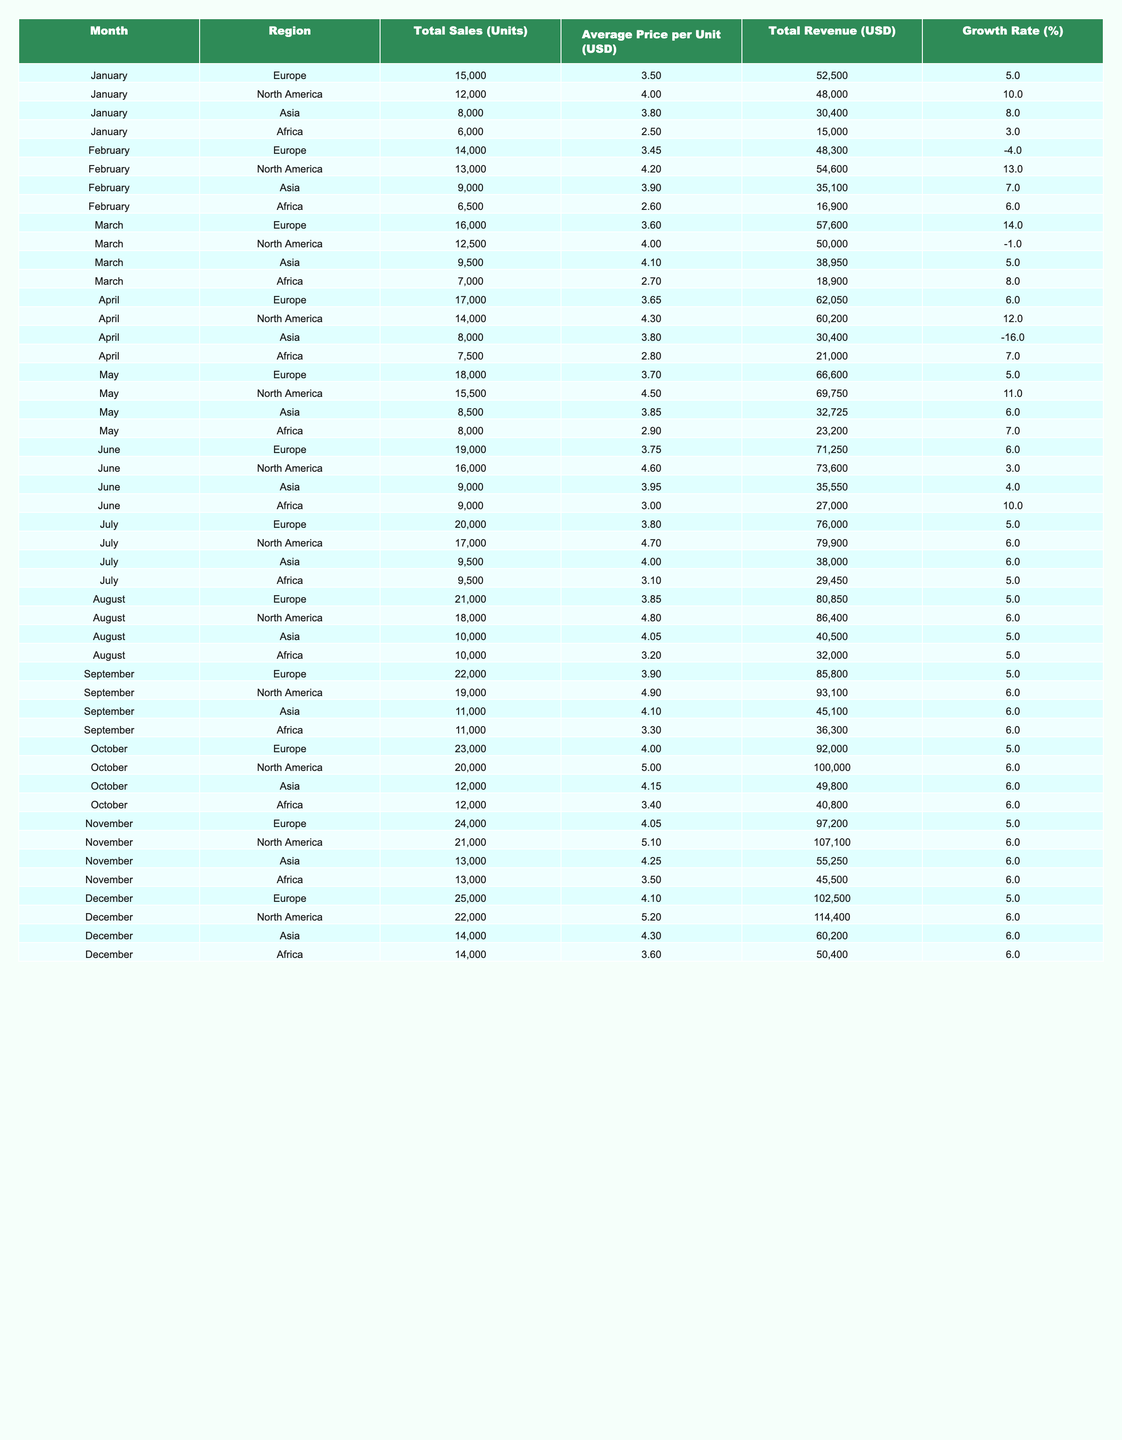What was the total revenue from citrus sales in Europe during November? In November, the total revenue from Europe is listed as $97,200.
Answer: $97,200 Which region had the highest average price per unit in October? In October, North America had the highest average price at $5.00 per unit.
Answer: North America What is the total number of units sold across all regions in December? The total units sold in December across all regions are: 25,000 (Europe) + 22,000 (North America) + 14,000 (Asia) + 14,000 (Africa) = 75,000 units.
Answer: 75,000 Did the sales in Asia grow in June? The growth rate for Asia in June is 4%, which indicates an increase in sales compared to previous months.
Answer: Yes What was the month with the highest total sales in North America? The month with the highest total sales in North America is November with 21,000 units sold.
Answer: November Calculate the average growth rate for Africa over the year. The growth rates for Africa by month are: 3, 6, 8, 7, 7, 10, 5, 5, 6, 6, 6, 6. The average growth rate is (3 + 6 + 8 + 7 + 7 + 10 + 5 + 5 + 6 + 6 + 6 + 6) / 12 = 6.08%.
Answer: 6.08% Which region has consistently increased total sales every month from January to December? Based on the sales data, Europe shows a consistent increase in total sales every month from January (15,000) to December (25,000).
Answer: Europe What was the average total revenue from sales in Africa across all months? The total revenues from Africa for each month are: 15,000, 16,900, 18,900, 21,000, 23,200, 27,000, 29,450, 32,000, 36,300, 40,800, 45,500, and 50,400. The average total revenue is calculated as the sum of revenues (15,000 + 16,900 + ... + 50,400) divided by 12, which equals $35,650.
Answer: $35,650 Identify the month with the lowest sales in Asia and what was the figure. The month with the lowest sales in Asia was April with 8,000 units sold.
Answer: April, 8,000 units Was the average price per unit in February lower than that in January for Africa? In January, the average price per unit in Africa was $2.50, while in February it was $2.60, which means it was higher in February.
Answer: No 